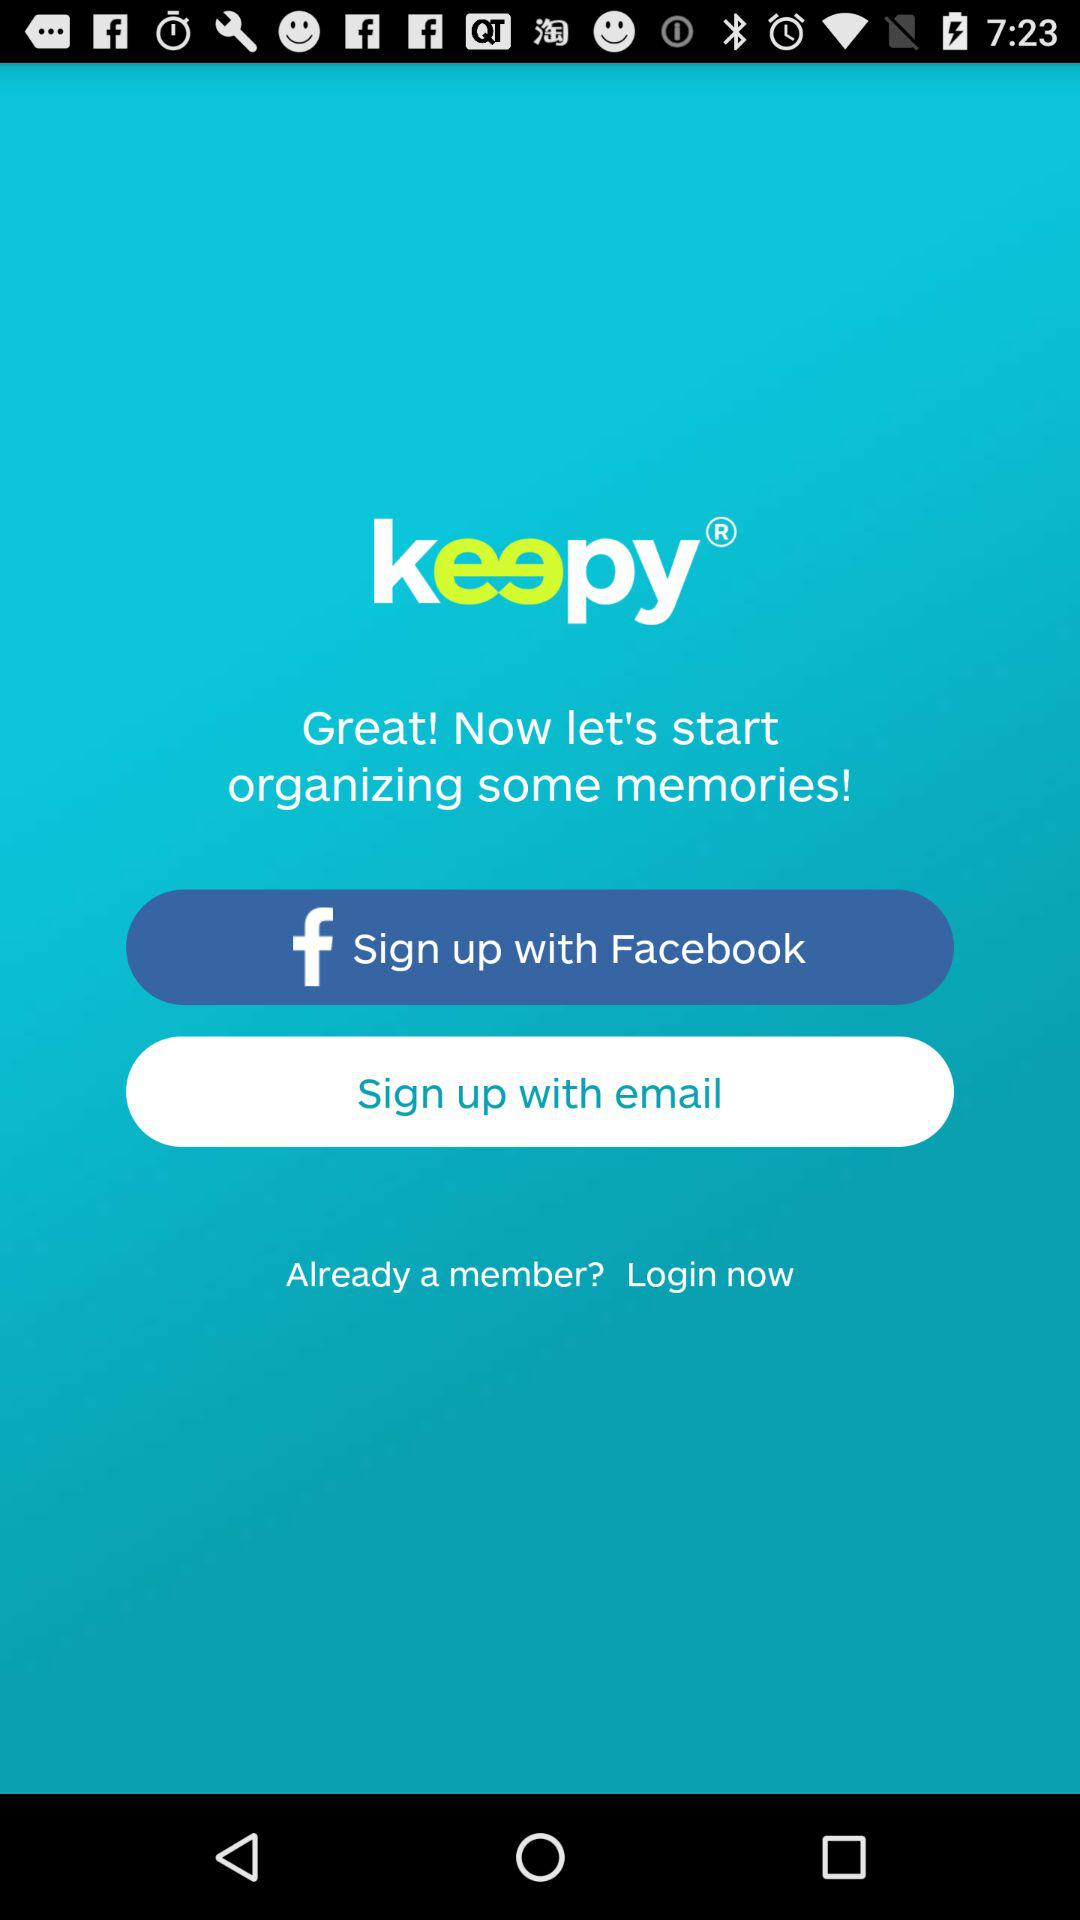What is the app name? The app name is "keepy". 